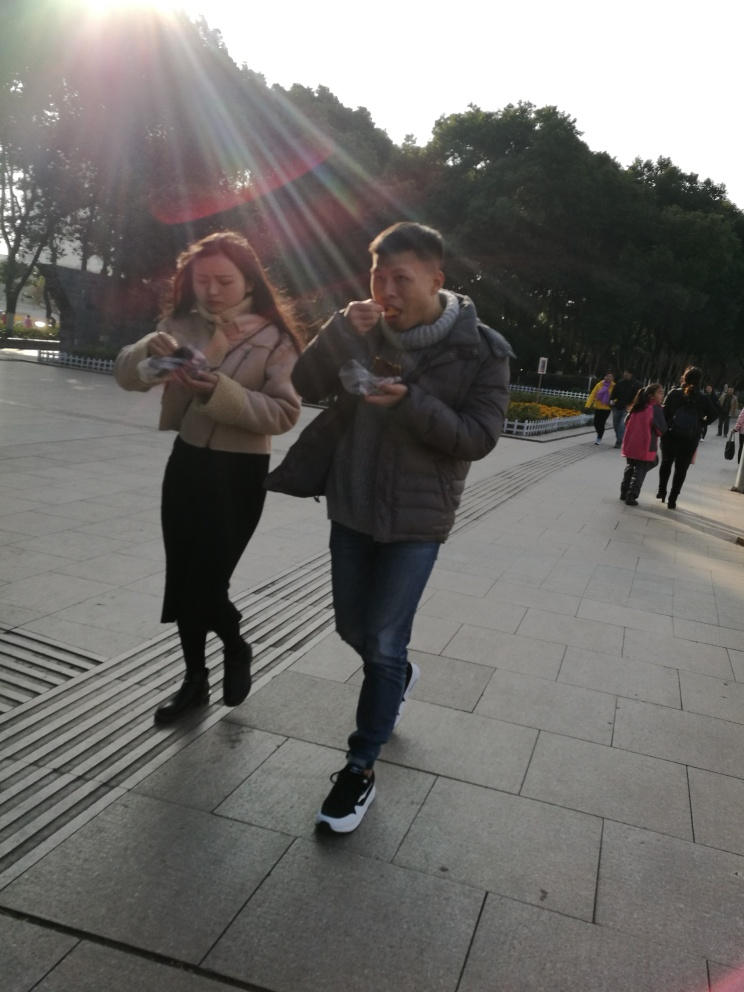What time of day does this photo appear to have been taken? The photo seems to have been captured in the late afternoon, as suggested by the position and angle of the long shadows and the warm sunlight. 